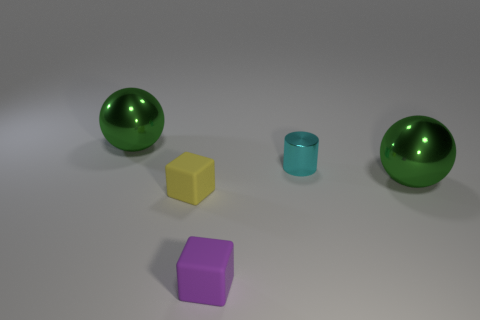There is another block that is the same size as the purple cube; what is its color?
Provide a short and direct response. Yellow. Is there any other thing that has the same shape as the small metal thing?
Ensure brevity in your answer.  No. What color is the other tiny rubber thing that is the same shape as the tiny yellow thing?
Your answer should be compact. Purple. What number of objects are big metal objects or objects that are to the right of the small yellow cube?
Offer a very short reply. 4. Are there fewer big green metal balls to the left of the tiny cyan metal cylinder than purple matte blocks?
Offer a very short reply. No. There is a ball that is behind the big metal object that is in front of the green metallic thing that is left of the yellow thing; how big is it?
Ensure brevity in your answer.  Large. There is a small thing that is behind the purple object and right of the tiny yellow object; what color is it?
Ensure brevity in your answer.  Cyan. How many rubber things are there?
Give a very brief answer. 2. Is the small cyan cylinder made of the same material as the purple block?
Provide a short and direct response. No. Is the size of the cube that is on the right side of the yellow rubber object the same as the block behind the purple rubber object?
Keep it short and to the point. Yes. 